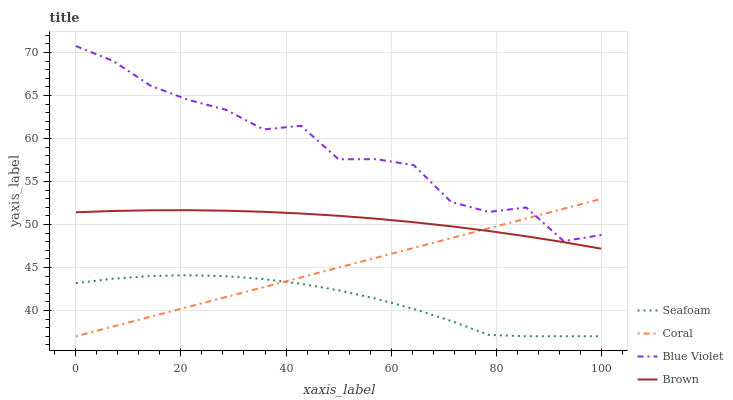Does Seafoam have the minimum area under the curve?
Answer yes or no. Yes. Does Blue Violet have the maximum area under the curve?
Answer yes or no. Yes. Does Coral have the minimum area under the curve?
Answer yes or no. No. Does Coral have the maximum area under the curve?
Answer yes or no. No. Is Coral the smoothest?
Answer yes or no. Yes. Is Blue Violet the roughest?
Answer yes or no. Yes. Is Seafoam the smoothest?
Answer yes or no. No. Is Seafoam the roughest?
Answer yes or no. No. Does Coral have the lowest value?
Answer yes or no. Yes. Does Blue Violet have the lowest value?
Answer yes or no. No. Does Blue Violet have the highest value?
Answer yes or no. Yes. Does Coral have the highest value?
Answer yes or no. No. Is Seafoam less than Blue Violet?
Answer yes or no. Yes. Is Brown greater than Seafoam?
Answer yes or no. Yes. Does Seafoam intersect Coral?
Answer yes or no. Yes. Is Seafoam less than Coral?
Answer yes or no. No. Is Seafoam greater than Coral?
Answer yes or no. No. Does Seafoam intersect Blue Violet?
Answer yes or no. No. 